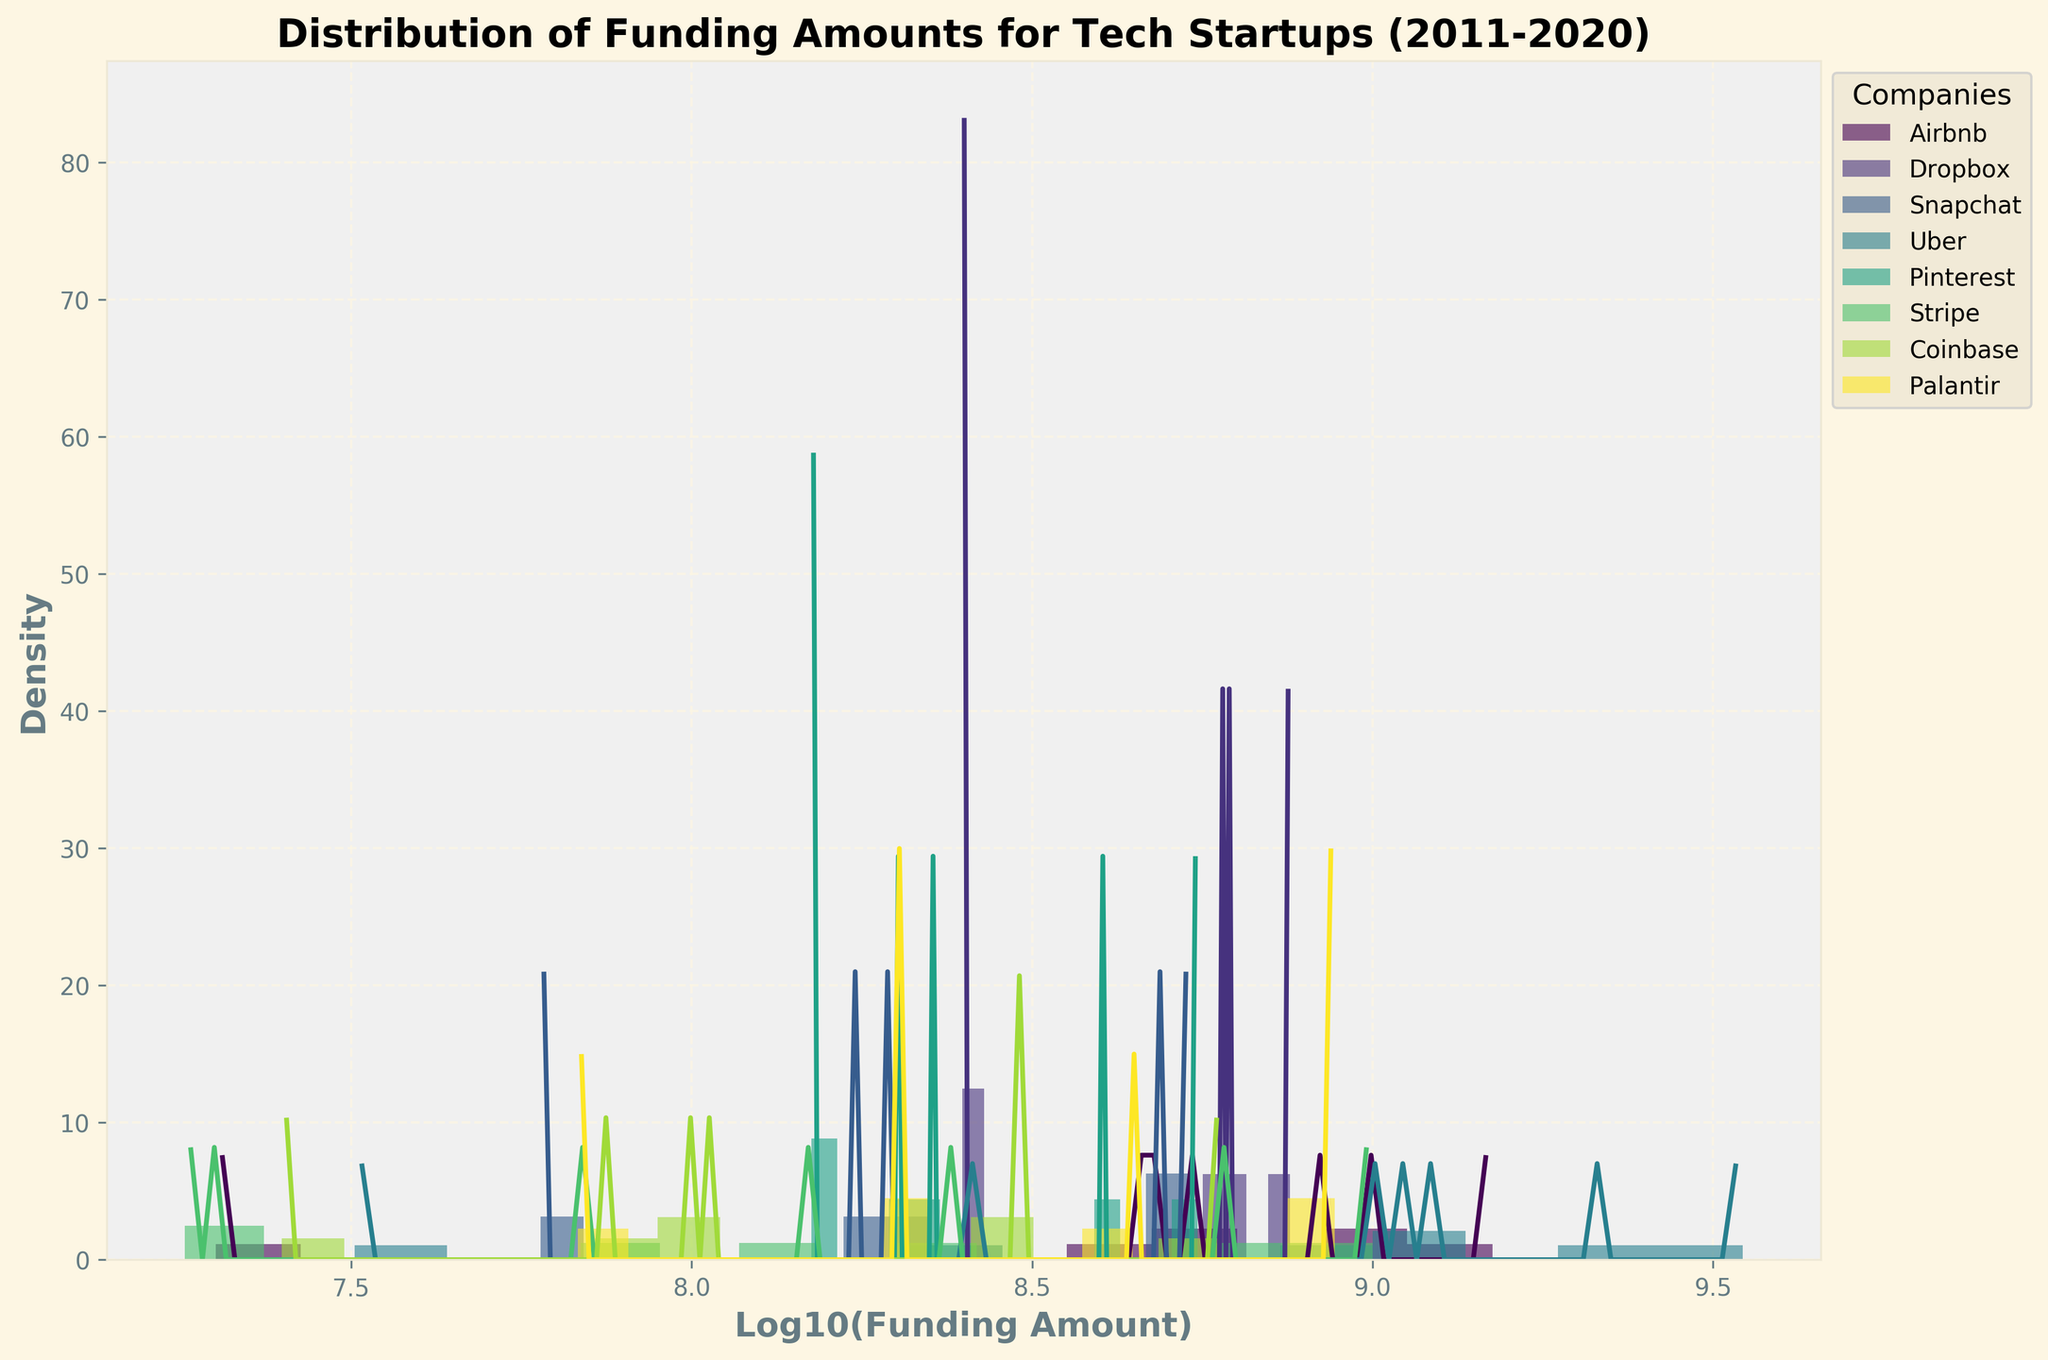What is the main title of the subplot? The main title of the subplot is located at the top of the figure and summarises the overall content depicted in the plot. It reads "Distribution of Funding Amounts for Tech Startups (2011-2020)".
Answer: Distribution of Funding Amounts for Tech Startups (2011-2020) Which axis represents the funding amount and how is it scaled? The x-axis represents the funding amounts, scaled using the common logarithm (base-10) to better visualize varying magnitudes of funding across companies.
Answer: Log10(Funding Amount) What does the y-axis represent in the subplot? The y-axis represents the density of funding amounts, which depicts how frequent particular funding levels occur within the log10-scaled funding amounts.
Answer: Density How many unique companies are shown in the subplot? Unique companies can be identified by the distinct colors and labels in the legend. In this case, there are 8 unique companies, each represented by a different color.
Answer: 8 Which company appears to have the highest peak density for their funding amounts? By observing the height of the highest peak from the density lines plotted for each company, Uber shows the highest peak density in the subplot.
Answer: Uber Among Palantir and Stripe, which company has a wider range of funding amounts based on the density distribution? By looking at the spread of the density distribution along the x-axis (log10 funding amount), Palantir's density line is more spread out compared to Stripe's, indicating a wider range of funding amounts.
Answer: Palantir What observation can you make about the density distribution of Airbnb's funding amounts? Airbnb's density distribution is multimodal, showing multiple peaks, indicating that its funding amounts fall into several distinct clusters across different levels.
Answer: Multimodal Do Pinterest's funding amounts appear to be more or less variable compared to Coinbase? Based on the spread of the density line of each company, Pinterest's funding amount distribution is narrower, indicating less variability compared to Coinbase's wider spread density distribution.
Answer: Less variable What does a higher density value indicate about the frequency of funding amounts? A higher density value indicates that the funding amounts falling within that log10 value range occur more frequently compared to those with lower density values.
Answer: More frequent 